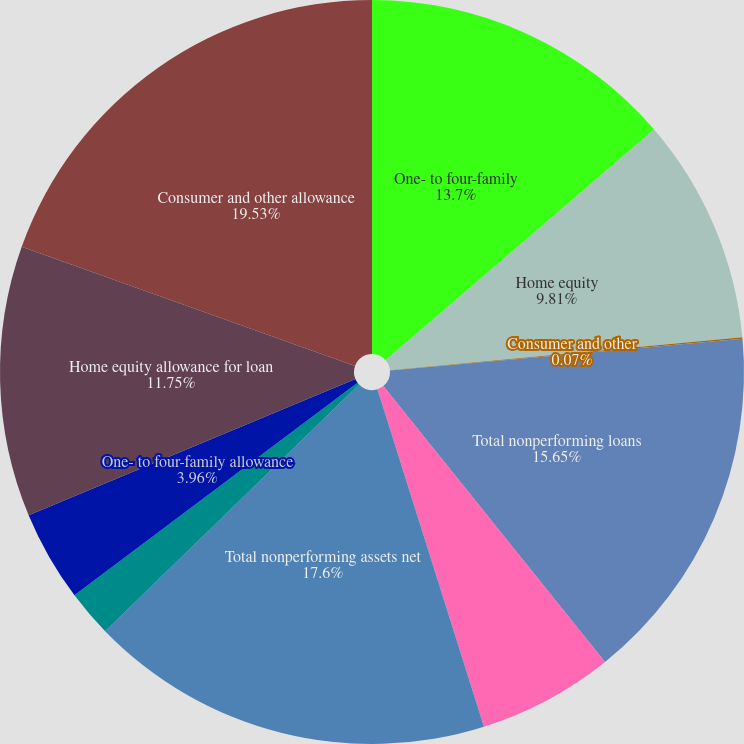<chart> <loc_0><loc_0><loc_500><loc_500><pie_chart><fcel>One- to four-family<fcel>Home equity<fcel>Consumer and other<fcel>Total nonperforming loans<fcel>Real estate owned and other<fcel>Total nonperforming assets net<fcel>Nonperforming loans receivable<fcel>One- to four-family allowance<fcel>Home equity allowance for loan<fcel>Consumer and other allowance<nl><fcel>13.7%<fcel>9.81%<fcel>0.07%<fcel>15.65%<fcel>5.91%<fcel>17.6%<fcel>2.02%<fcel>3.96%<fcel>11.75%<fcel>19.54%<nl></chart> 